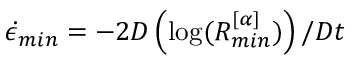<formula> <loc_0><loc_0><loc_500><loc_500>\dot { \epsilon } _ { \min } = - 2 D \left ( \log ( R _ { \min } ^ { [ \alpha ] } ) \right ) / D t</formula> 